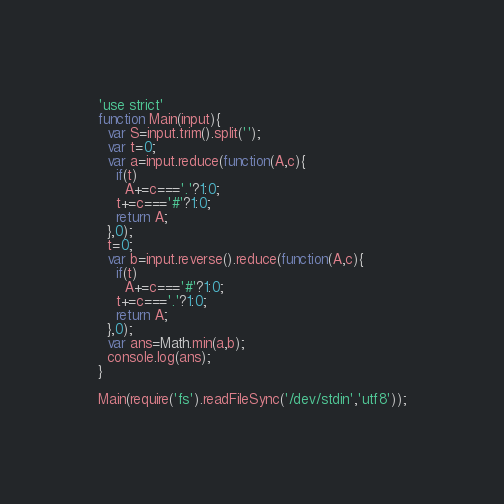Convert code to text. <code><loc_0><loc_0><loc_500><loc_500><_JavaScript_>'use strict'
function Main(input){
  var S=input.trim().split('');
  var t=0;
  var a=input.reduce(function(A,c){
    if(t)
      A+=c==='.'?1:0;
    t+=c==='#'?1:0;
    return A;
  },0);
  t=0;
  var b=input.reverse().reduce(function(A,c){
    if(t)
      A+=c==='#'?1:0;
    t+=c==='.'?1:0;
    return A;
  },0);
  var ans=Math.min(a,b);
  console.log(ans);
}

Main(require('fs').readFileSync('/dev/stdin','utf8'));</code> 